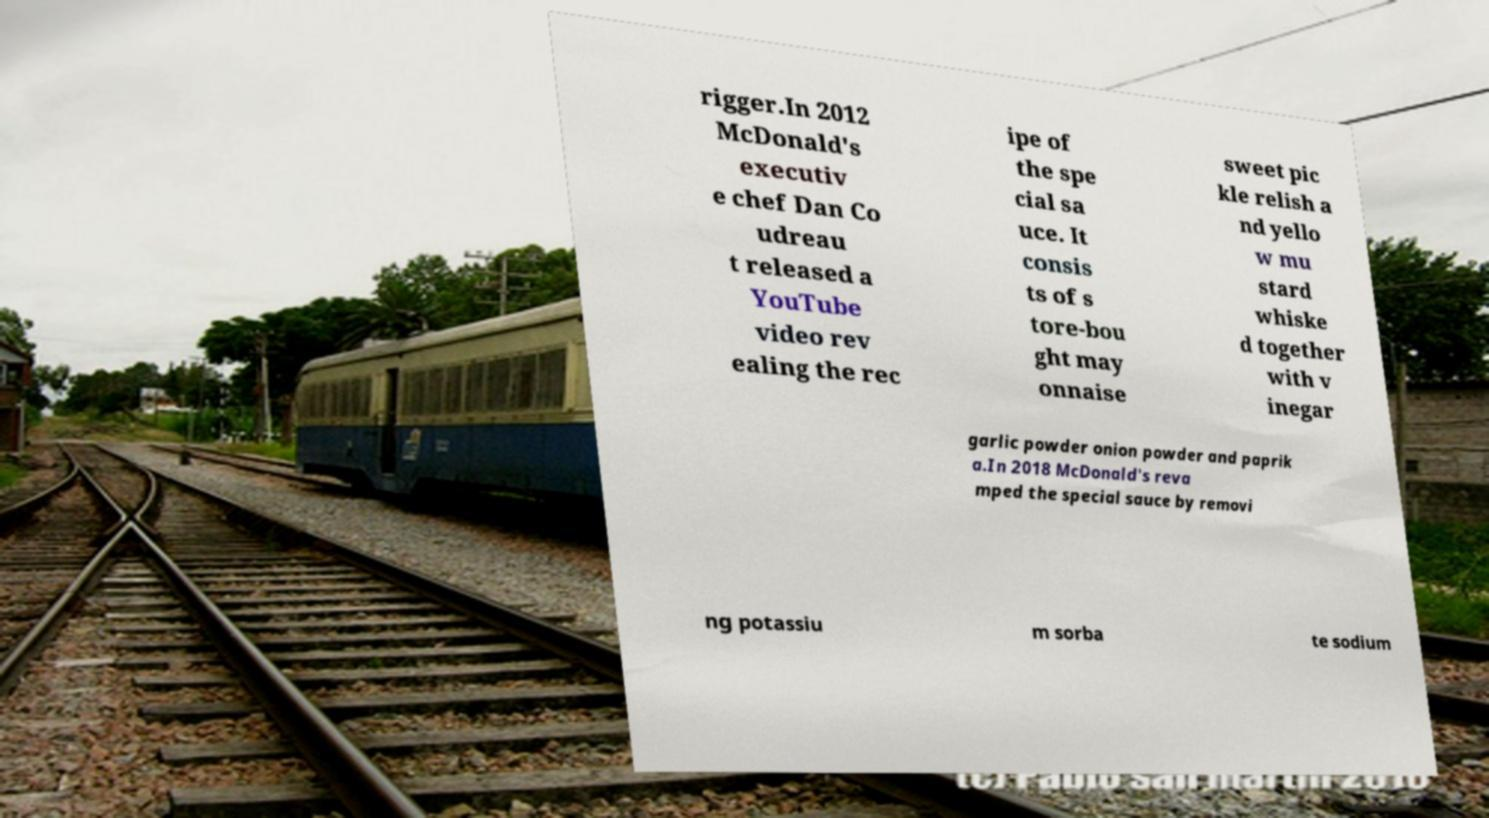There's text embedded in this image that I need extracted. Can you transcribe it verbatim? rigger.In 2012 McDonald's executiv e chef Dan Co udreau t released a YouTube video rev ealing the rec ipe of the spe cial sa uce. It consis ts of s tore-bou ght may onnaise sweet pic kle relish a nd yello w mu stard whiske d together with v inegar garlic powder onion powder and paprik a.In 2018 McDonald's reva mped the special sauce by removi ng potassiu m sorba te sodium 